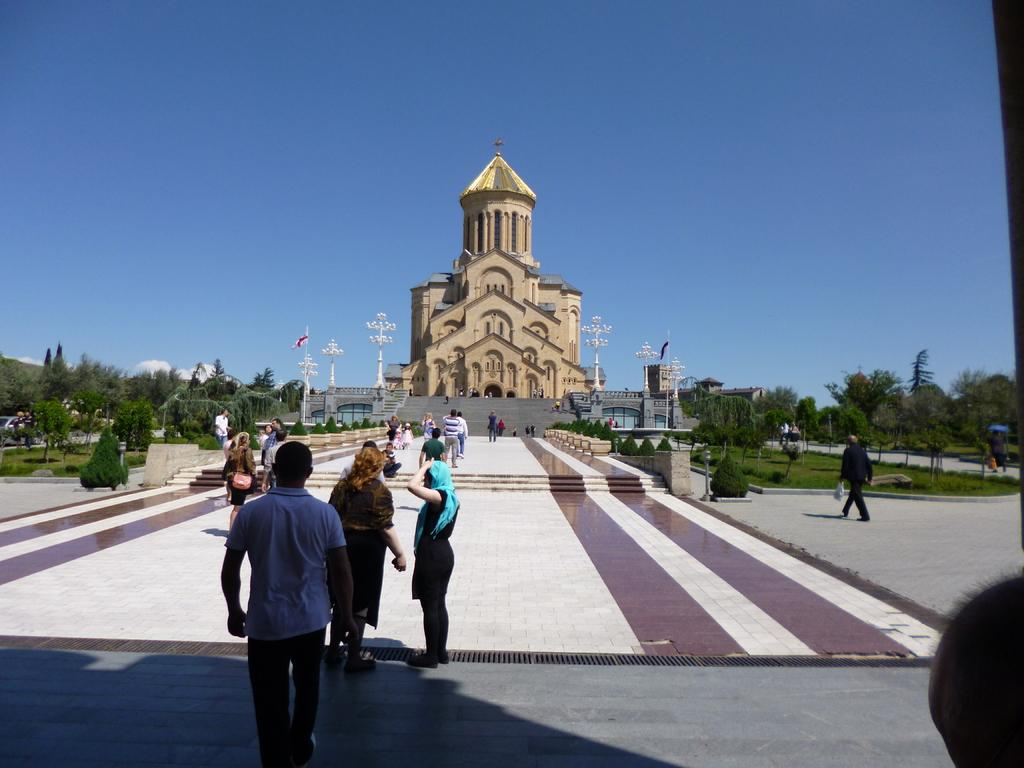What are the people in the image doing? The people in the image are walking and standing on a path. Where does the path lead to? The path leads towards a castle. What can be seen on either side of the path? There are trees on either side of the path. What is visible above the castle? The sky is visible above the castle. Is the ground made of quicksand in the image? There is no mention of quicksand in the image, and the ground appears to be a regular path. Can you see anyone burning in the image? There is no indication of fire or burning in the image. 